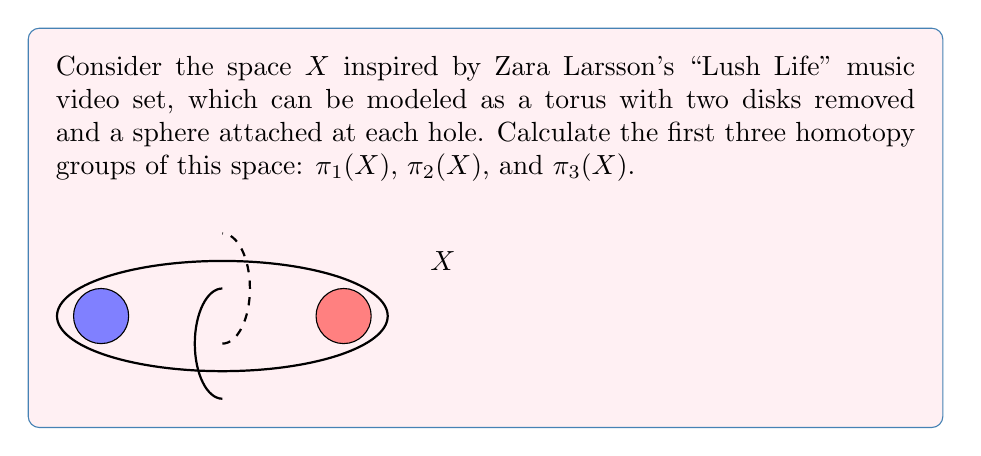Help me with this question. Let's approach this step-by-step:

1) First, let's consider the fundamental group $\pi_1(X)$:
   - The torus with two disks removed is homotopy equivalent to a wedge of two circles.
   - Attaching spheres doesn't affect the fundamental group.
   - Therefore, $\pi_1(X) \cong \mathbb{Z} * \mathbb{Z}$, the free group on two generators.

2) For $\pi_2(X)$:
   - The torus with holes doesn't contribute to $\pi_2$.
   - Each attached sphere contributes a $\mathbb{Z}$ to $\pi_2$.
   - Thus, $\pi_2(X) \cong \mathbb{Z} \oplus \mathbb{Z}$.

3) For $\pi_3(X)$:
   - The torus with holes doesn't contribute to $\pi_3$.
   - Each sphere contributes its own $\pi_3(S^2) \cong \mathbb{Z}$.
   - The Hurewicz theorem states that $\pi_3(S^2) \cong \mathbb{Z}$, generated by the Hopf fibration.
   - Therefore, $\pi_3(X) \cong \mathbb{Z} \oplus \mathbb{Z}$.

4) We can summarize these results using the wedge sum notation:
   $X \simeq (S^1 \vee S^1) \vee S^2 \vee S^2$

This decomposition clearly shows the contributions to each homotopy group.
Answer: $\pi_1(X) \cong \mathbb{Z} * \mathbb{Z}$, $\pi_2(X) \cong \mathbb{Z} \oplus \mathbb{Z}$, $\pi_3(X) \cong \mathbb{Z} \oplus \mathbb{Z}$ 